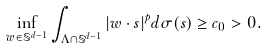<formula> <loc_0><loc_0><loc_500><loc_500>\inf _ { { w } \in \mathbb { S } ^ { d - 1 } } \int _ { \Lambda \cap \mathbb { S } ^ { d - 1 } } | { w } \cdot { s } | ^ { p } d \sigma ( { s } ) \geq c _ { 0 } > 0 .</formula> 